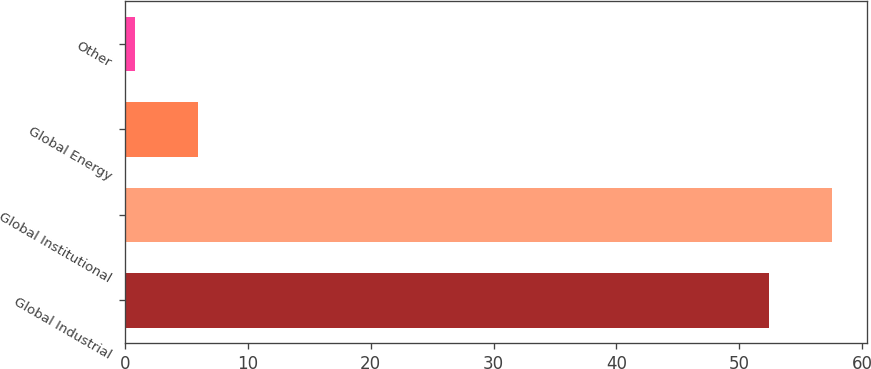Convert chart. <chart><loc_0><loc_0><loc_500><loc_500><bar_chart><fcel>Global Industrial<fcel>Global Institutional<fcel>Global Energy<fcel>Other<nl><fcel>52.4<fcel>57.56<fcel>5.96<fcel>0.8<nl></chart> 